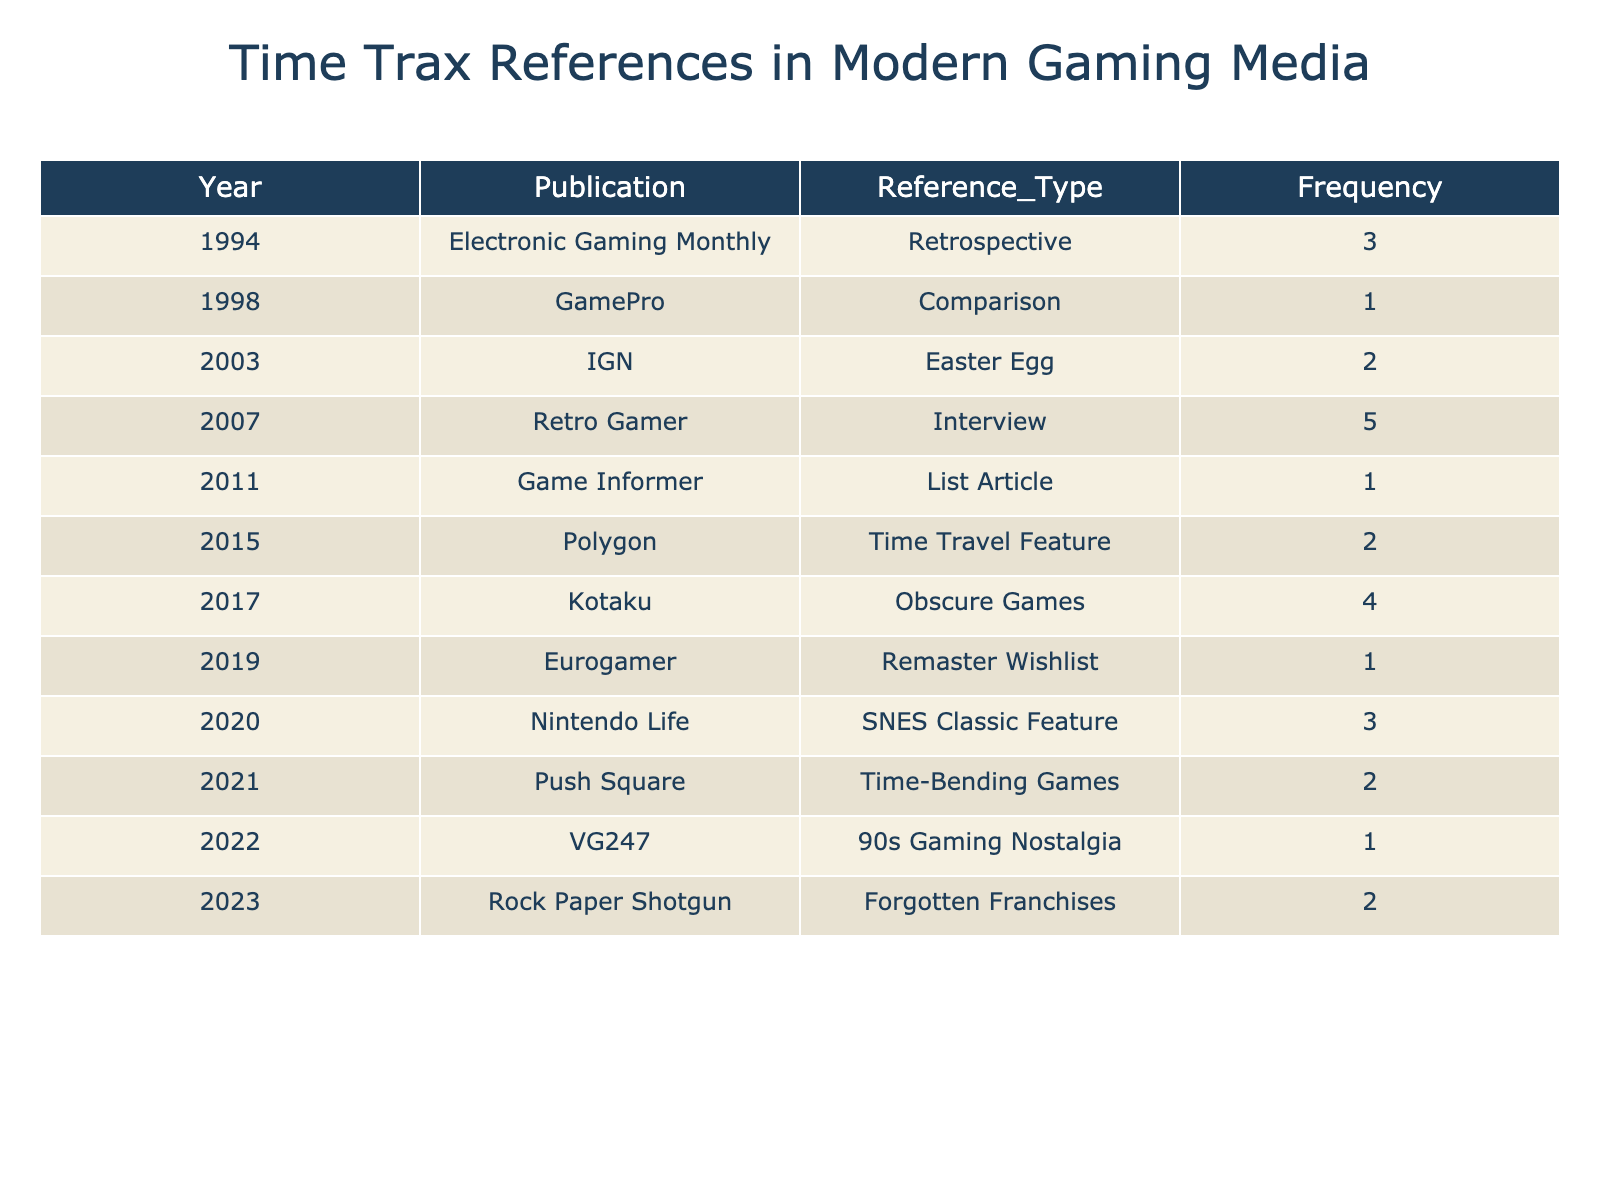What is the highest frequency of Time Trax references recorded in a single publication? The table shows that the highest frequency is 5, recorded in the 2007 article by Retro Gamer.
Answer: 5 Which year saw the lowest frequency of Time Trax references in the table? In 1998, GamePro recorded a frequency of 1, which is the lowest value in the table.
Answer: 1998 How many references to Time Trax were made in total across all publications? To find the total, we sum all the frequencies: 3 + 1 + 2 + 5 + 1 + 2 + 4 + 1 + 3 + 2 + 1 + 2 = 27.
Answer: 27 In how many publications was Time Trax referenced more than 2 times? The publications with references greater than 2 times are: Retro Gamer (5), Kotaku (4), and Electronic Gaming Monthly (3). That's a total of 3 publications.
Answer: 3 What is the average frequency of Time Trax references from the table? To find the average, we divide the total frequency (27) by the number of entries (12): 27/12 = 2.25.
Answer: 2.25 Was there any publication in the table that referenced Time Trax in a List Article format? Yes, Game Informer referenced Time Trax in a List Article format in 2011.
Answer: Yes Which reference type had the highest total frequency across all the years? By evaluating the types, we identify: Retrospective (3), Comparison (1), Easter Egg (2), Interview (5), List Article (1), Time Travel Feature (2), Obscure Games (4), Remaster Wishlist (1), SNES Classic Feature (3), Time-Bending Games (2), 90s Gaming Nostalgia (1), Forgotten Franchises (2). The Interview type has the highest frequency of 5.
Answer: Interview Were there any mentions of Time Trax in the context of nostalgia-themed articles? Yes, the article by VG247 in 2022 included 1 mention under 90s Gaming Nostalgia, and there is a 2015 Polygon article referencing time travel, but it is not nostalgia-specific.
Answer: Yes What is the difference in frequency between the earliest and latest references in the table? The earliest reference in 1994 had a frequency of 3, while the latest reference in 2023 had a frequency of 2. The difference is 3 - 2 = 1.
Answer: 1 Which publication had Time Trax mentioned in the context of time-bending games? Push Square mentioned Time Trax in the context of time-bending games in 2021, with a frequency of 2.
Answer: Push Square 